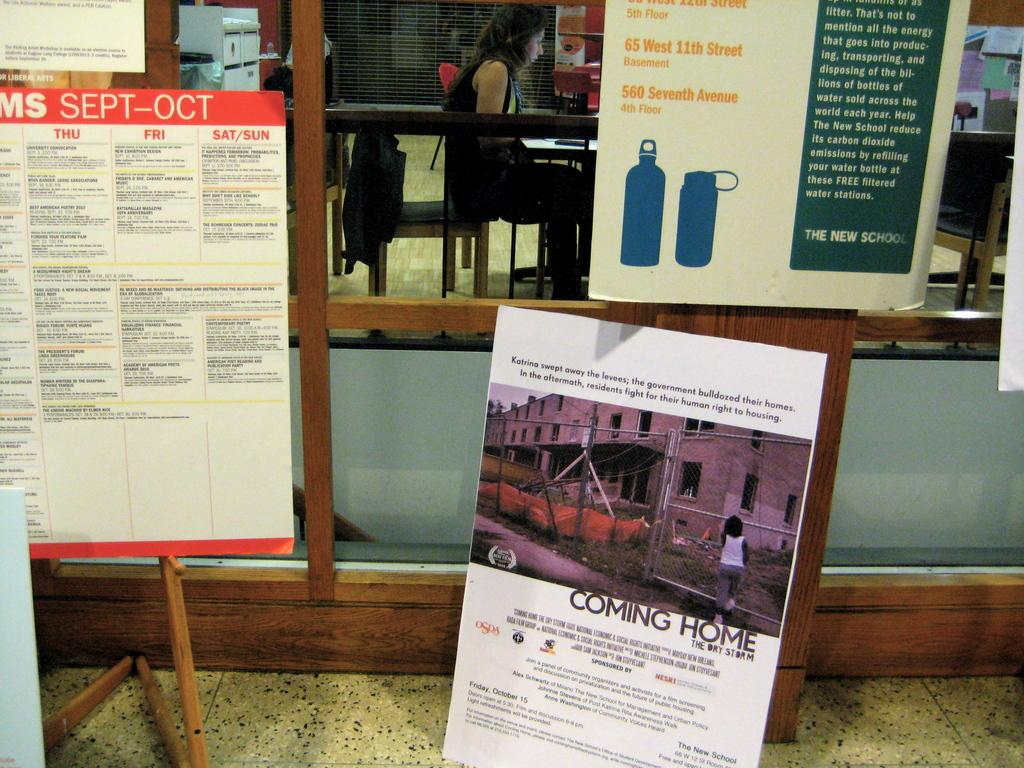<image>
Create a compact narrative representing the image presented. Multiple posters one of which says Coming Home The Dry Storm. 